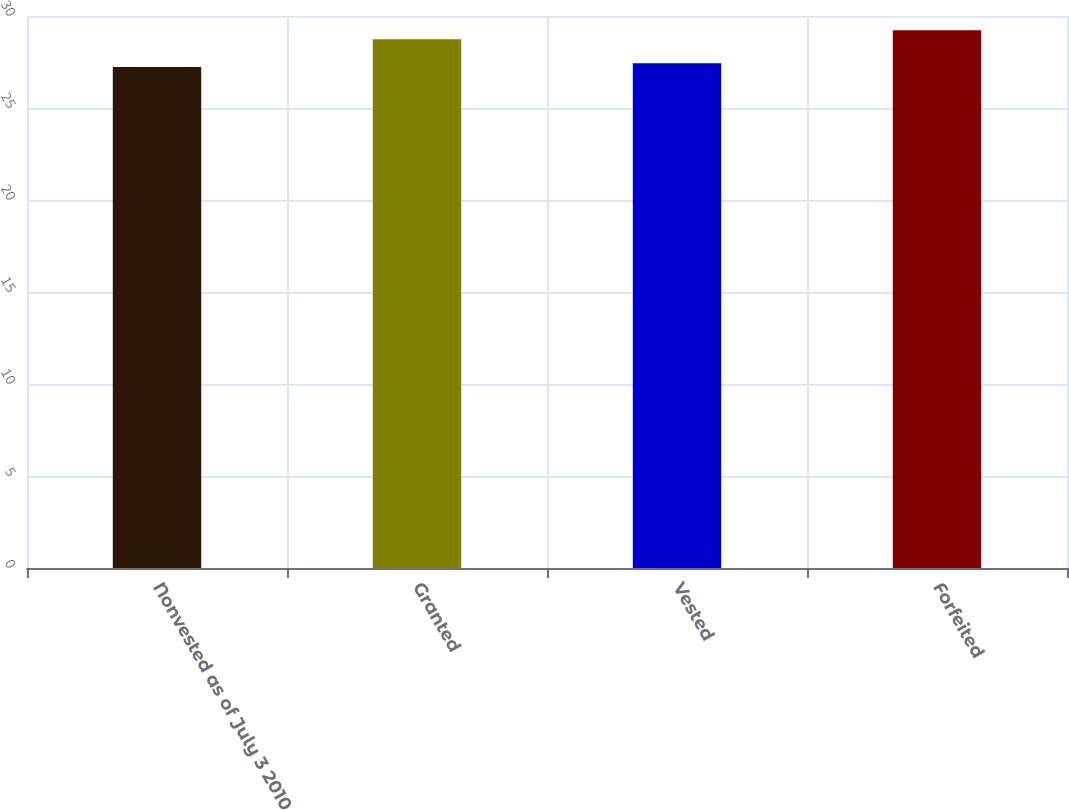Convert chart. <chart><loc_0><loc_0><loc_500><loc_500><bar_chart><fcel>Nonvested as of July 3 2010<fcel>Granted<fcel>Vested<fcel>Forfeited<nl><fcel>27.23<fcel>28.73<fcel>27.43<fcel>29.22<nl></chart> 